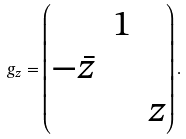Convert formula to latex. <formula><loc_0><loc_0><loc_500><loc_500>g _ { z } = \begin{pmatrix} & 1 & \\ - \bar { z } & & \\ & & z \end{pmatrix} .</formula> 